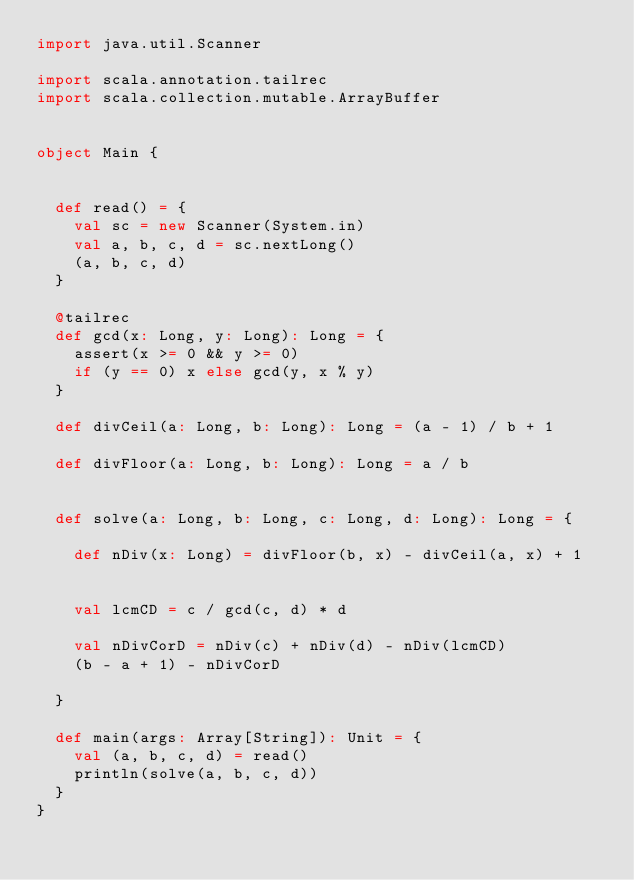<code> <loc_0><loc_0><loc_500><loc_500><_Scala_>import java.util.Scanner

import scala.annotation.tailrec
import scala.collection.mutable.ArrayBuffer


object Main {


  def read() = {
    val sc = new Scanner(System.in)
    val a, b, c, d = sc.nextLong()
    (a, b, c, d)
  }

  @tailrec
  def gcd(x: Long, y: Long): Long = {
    assert(x >= 0 && y >= 0)
    if (y == 0) x else gcd(y, x % y)
  }

  def divCeil(a: Long, b: Long): Long = (a - 1) / b + 1

  def divFloor(a: Long, b: Long): Long = a / b


  def solve(a: Long, b: Long, c: Long, d: Long): Long = {

    def nDiv(x: Long) = divFloor(b, x) - divCeil(a, x) + 1


    val lcmCD = c / gcd(c, d) * d

    val nDivCorD = nDiv(c) + nDiv(d) - nDiv(lcmCD)
    (b - a + 1) - nDivCorD

  }

  def main(args: Array[String]): Unit = {
    val (a, b, c, d) = read()
    println(solve(a, b, c, d))
  }
}</code> 